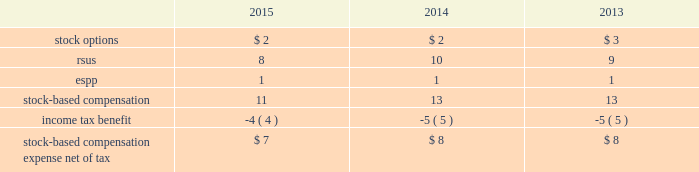Note 9 : stock based compensation the company has granted stock option and restricted stock unit ( 201crsus 201d ) awards to non-employee directors , officers and other key employees of the company pursuant to the terms of its 2007 omnibus equity compensation plan ( the 201c2007 plan 201d ) .
The total aggregate number of shares of common stock that may be issued under the 2007 plan is 15.5 .
As of december 31 , 2015 , 8.4 shares were available for grant under the 2007 plan .
Shares issued under the 2007 plan may be authorized-but-unissued shares of company stock or reacquired shares of company stock , including shares purchased by the company on the open market .
The company recognizes compensation expense for stock awards over the vesting period of the award .
The table presents stock-based compensation expense recorded in operation and maintenance expense in the accompanying consolidated statements of operations for the years ended december 31: .
There were no significant stock-based compensation costs capitalized during the years ended december 31 , 2015 , 2014 and 2013 .
The cost of services received from employees in exchange for the issuance of stock options and restricted stock awards is measured based on the grant date fair value of the awards issued .
The value of stock options and rsus awards at the date of the grant is amortized through expense over the three-year service period .
All awards granted in 2015 , 2014 and 2013 are classified as equity .
The company receives a tax deduction based on the intrinsic value of the award at the exercise date for stock options and the distribution date for rsus .
For each award , throughout the requisite service period , the company recognizes the tax benefits , which have been included in deferred income tax assets , related to compensation costs .
The tax deductions in excess of the benefits recorded throughout the requisite service period are recorded to common stockholders 2019 equity or the statement of operations and are presented in the financing section of the consolidated statements of cash flows .
The company stratified its grant populations and used historic employee turnover rates to estimate employee forfeitures .
The estimated rate is compared to the actual forfeitures at the end of the reporting period and adjusted as necessary .
Stock options in 2015 , 2014 and 2013 , the company granted non-qualified stock options to certain employees under the 2007 plan .
The stock options vest ratably over the three-year service period beginning on january 1 of the year of the grant .
These awards have no performance vesting conditions and the grant date fair value is amortized through expense over the requisite service period using the straight-line method and is included in operations and maintenance expense in the accompanying consolidated statements of operations. .
At what tax rate was stock-based compensation taxed at in 2018? 
Computations: (11 / 4)
Answer: 2.75. 